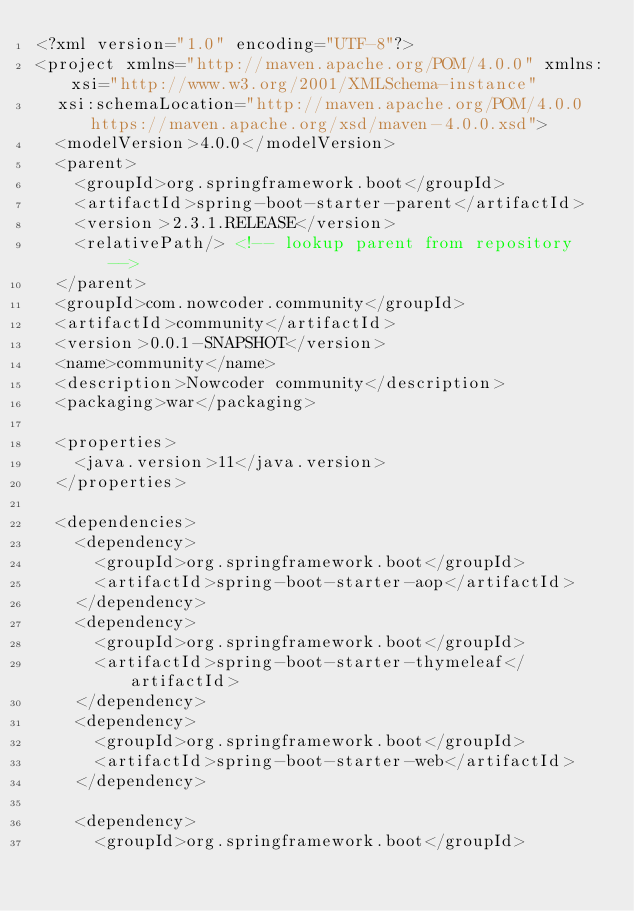Convert code to text. <code><loc_0><loc_0><loc_500><loc_500><_XML_><?xml version="1.0" encoding="UTF-8"?>
<project xmlns="http://maven.apache.org/POM/4.0.0" xmlns:xsi="http://www.w3.org/2001/XMLSchema-instance"
	xsi:schemaLocation="http://maven.apache.org/POM/4.0.0 https://maven.apache.org/xsd/maven-4.0.0.xsd">
	<modelVersion>4.0.0</modelVersion>
	<parent>
		<groupId>org.springframework.boot</groupId>
		<artifactId>spring-boot-starter-parent</artifactId>
		<version>2.3.1.RELEASE</version>
		<relativePath/> <!-- lookup parent from repository -->
	</parent>
	<groupId>com.nowcoder.community</groupId>
	<artifactId>community</artifactId>
	<version>0.0.1-SNAPSHOT</version>
	<name>community</name>
	<description>Nowcoder community</description>
	<packaging>war</packaging>

	<properties>
		<java.version>11</java.version>
	</properties>

	<dependencies>
		<dependency>
			<groupId>org.springframework.boot</groupId>
			<artifactId>spring-boot-starter-aop</artifactId>
		</dependency>
		<dependency>
			<groupId>org.springframework.boot</groupId>
			<artifactId>spring-boot-starter-thymeleaf</artifactId>
		</dependency>
		<dependency>
			<groupId>org.springframework.boot</groupId>
			<artifactId>spring-boot-starter-web</artifactId>
		</dependency>

		<dependency>
			<groupId>org.springframework.boot</groupId></code> 